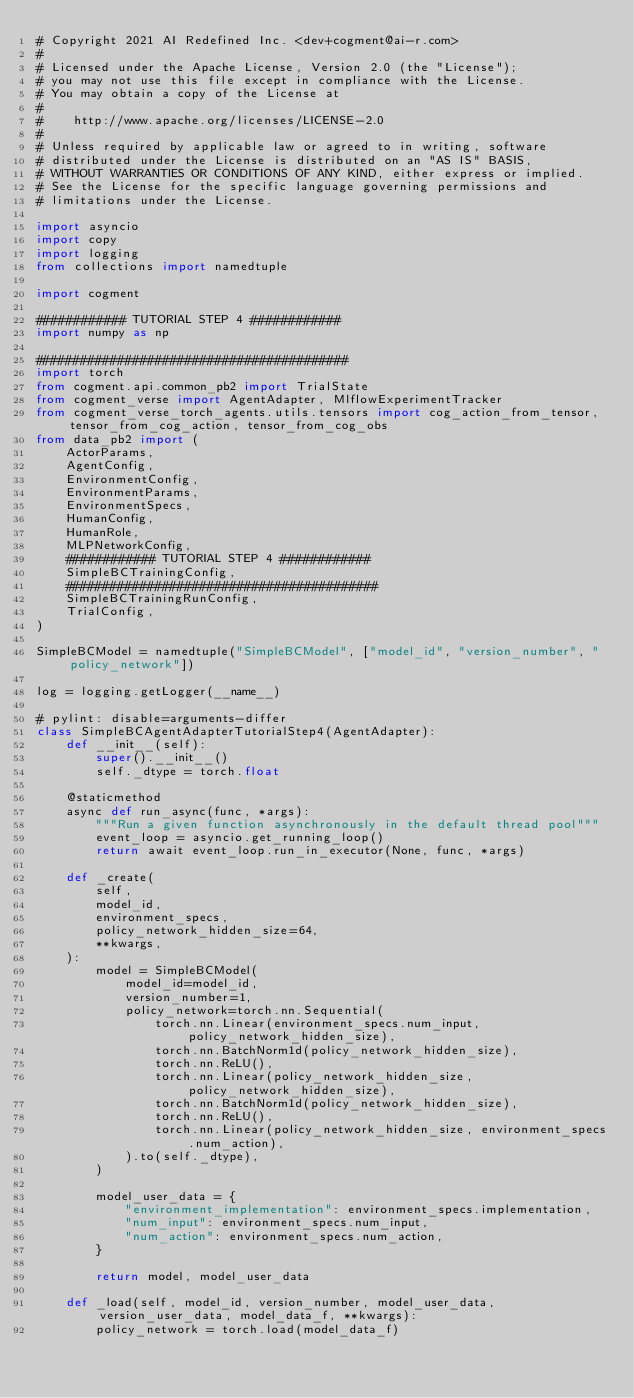Convert code to text. <code><loc_0><loc_0><loc_500><loc_500><_Python_># Copyright 2021 AI Redefined Inc. <dev+cogment@ai-r.com>
#
# Licensed under the Apache License, Version 2.0 (the "License");
# you may not use this file except in compliance with the License.
# You may obtain a copy of the License at
#
#    http://www.apache.org/licenses/LICENSE-2.0
#
# Unless required by applicable law or agreed to in writing, software
# distributed under the License is distributed on an "AS IS" BASIS,
# WITHOUT WARRANTIES OR CONDITIONS OF ANY KIND, either express or implied.
# See the License for the specific language governing permissions and
# limitations under the License.

import asyncio
import copy
import logging
from collections import namedtuple

import cogment

############ TUTORIAL STEP 4 ############
import numpy as np

##########################################
import torch
from cogment.api.common_pb2 import TrialState
from cogment_verse import AgentAdapter, MlflowExperimentTracker
from cogment_verse_torch_agents.utils.tensors import cog_action_from_tensor, tensor_from_cog_action, tensor_from_cog_obs
from data_pb2 import (
    ActorParams,
    AgentConfig,
    EnvironmentConfig,
    EnvironmentParams,
    EnvironmentSpecs,
    HumanConfig,
    HumanRole,
    MLPNetworkConfig,
    ############ TUTORIAL STEP 4 ############
    SimpleBCTrainingConfig,
    ##########################################
    SimpleBCTrainingRunConfig,
    TrialConfig,
)

SimpleBCModel = namedtuple("SimpleBCModel", ["model_id", "version_number", "policy_network"])

log = logging.getLogger(__name__)

# pylint: disable=arguments-differ
class SimpleBCAgentAdapterTutorialStep4(AgentAdapter):
    def __init__(self):
        super().__init__()
        self._dtype = torch.float

    @staticmethod
    async def run_async(func, *args):
        """Run a given function asynchronously in the default thread pool"""
        event_loop = asyncio.get_running_loop()
        return await event_loop.run_in_executor(None, func, *args)

    def _create(
        self,
        model_id,
        environment_specs,
        policy_network_hidden_size=64,
        **kwargs,
    ):
        model = SimpleBCModel(
            model_id=model_id,
            version_number=1,
            policy_network=torch.nn.Sequential(
                torch.nn.Linear(environment_specs.num_input, policy_network_hidden_size),
                torch.nn.BatchNorm1d(policy_network_hidden_size),
                torch.nn.ReLU(),
                torch.nn.Linear(policy_network_hidden_size, policy_network_hidden_size),
                torch.nn.BatchNorm1d(policy_network_hidden_size),
                torch.nn.ReLU(),
                torch.nn.Linear(policy_network_hidden_size, environment_specs.num_action),
            ).to(self._dtype),
        )

        model_user_data = {
            "environment_implementation": environment_specs.implementation,
            "num_input": environment_specs.num_input,
            "num_action": environment_specs.num_action,
        }

        return model, model_user_data

    def _load(self, model_id, version_number, model_user_data, version_user_data, model_data_f, **kwargs):
        policy_network = torch.load(model_data_f)</code> 